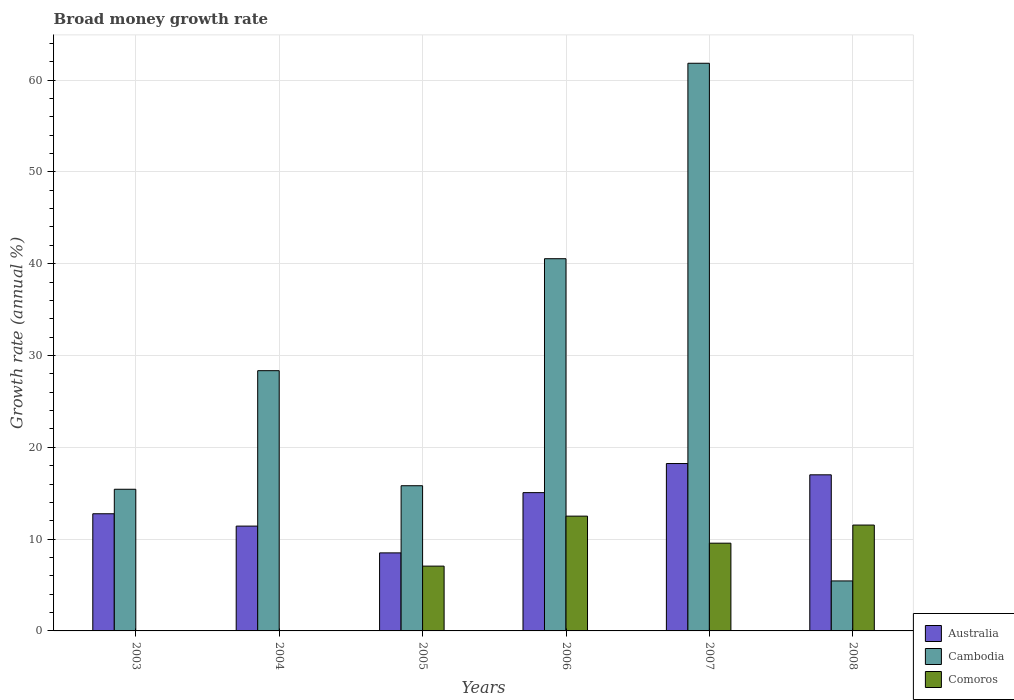Are the number of bars on each tick of the X-axis equal?
Your answer should be very brief. No. What is the growth rate in Comoros in 2008?
Provide a succinct answer. 11.53. Across all years, what is the maximum growth rate in Comoros?
Give a very brief answer. 12.5. Across all years, what is the minimum growth rate in Comoros?
Provide a succinct answer. 0. What is the total growth rate in Comoros in the graph?
Provide a short and direct response. 40.65. What is the difference between the growth rate in Cambodia in 2004 and that in 2005?
Your response must be concise. 12.53. What is the difference between the growth rate in Comoros in 2006 and the growth rate in Australia in 2004?
Your answer should be compact. 1.09. What is the average growth rate in Cambodia per year?
Offer a terse response. 27.9. In the year 2007, what is the difference between the growth rate in Cambodia and growth rate in Comoros?
Your answer should be very brief. 52.28. In how many years, is the growth rate in Cambodia greater than 2 %?
Offer a terse response. 6. What is the ratio of the growth rate in Cambodia in 2003 to that in 2004?
Provide a short and direct response. 0.54. Is the difference between the growth rate in Cambodia in 2005 and 2008 greater than the difference between the growth rate in Comoros in 2005 and 2008?
Provide a succinct answer. Yes. What is the difference between the highest and the second highest growth rate in Australia?
Provide a short and direct response. 1.23. What is the difference between the highest and the lowest growth rate in Australia?
Offer a terse response. 9.73. Is the sum of the growth rate in Cambodia in 2004 and 2005 greater than the maximum growth rate in Comoros across all years?
Give a very brief answer. Yes. Is it the case that in every year, the sum of the growth rate in Comoros and growth rate in Cambodia is greater than the growth rate in Australia?
Offer a terse response. No. How many bars are there?
Give a very brief answer. 16. Does the graph contain grids?
Ensure brevity in your answer.  Yes. How many legend labels are there?
Keep it short and to the point. 3. How are the legend labels stacked?
Make the answer very short. Vertical. What is the title of the graph?
Give a very brief answer. Broad money growth rate. Does "France" appear as one of the legend labels in the graph?
Your answer should be very brief. No. What is the label or title of the X-axis?
Your response must be concise. Years. What is the label or title of the Y-axis?
Provide a short and direct response. Growth rate (annual %). What is the Growth rate (annual %) in Australia in 2003?
Make the answer very short. 12.76. What is the Growth rate (annual %) of Cambodia in 2003?
Ensure brevity in your answer.  15.43. What is the Growth rate (annual %) of Comoros in 2003?
Provide a short and direct response. 0. What is the Growth rate (annual %) in Australia in 2004?
Provide a succinct answer. 11.42. What is the Growth rate (annual %) of Cambodia in 2004?
Provide a succinct answer. 28.35. What is the Growth rate (annual %) in Comoros in 2004?
Your answer should be very brief. 0. What is the Growth rate (annual %) in Australia in 2005?
Ensure brevity in your answer.  8.5. What is the Growth rate (annual %) in Cambodia in 2005?
Provide a succinct answer. 15.82. What is the Growth rate (annual %) of Comoros in 2005?
Keep it short and to the point. 7.06. What is the Growth rate (annual %) of Australia in 2006?
Offer a terse response. 15.06. What is the Growth rate (annual %) in Cambodia in 2006?
Offer a terse response. 40.55. What is the Growth rate (annual %) in Comoros in 2006?
Your response must be concise. 12.5. What is the Growth rate (annual %) of Australia in 2007?
Your answer should be very brief. 18.23. What is the Growth rate (annual %) in Cambodia in 2007?
Your answer should be very brief. 61.84. What is the Growth rate (annual %) of Comoros in 2007?
Keep it short and to the point. 9.56. What is the Growth rate (annual %) in Australia in 2008?
Offer a very short reply. 17. What is the Growth rate (annual %) in Cambodia in 2008?
Offer a terse response. 5.45. What is the Growth rate (annual %) in Comoros in 2008?
Provide a short and direct response. 11.53. Across all years, what is the maximum Growth rate (annual %) of Australia?
Provide a succinct answer. 18.23. Across all years, what is the maximum Growth rate (annual %) in Cambodia?
Your response must be concise. 61.84. Across all years, what is the maximum Growth rate (annual %) in Comoros?
Your response must be concise. 12.5. Across all years, what is the minimum Growth rate (annual %) in Australia?
Provide a short and direct response. 8.5. Across all years, what is the minimum Growth rate (annual %) of Cambodia?
Provide a succinct answer. 5.45. Across all years, what is the minimum Growth rate (annual %) in Comoros?
Your answer should be compact. 0. What is the total Growth rate (annual %) in Australia in the graph?
Provide a succinct answer. 82.98. What is the total Growth rate (annual %) of Cambodia in the graph?
Provide a short and direct response. 167.43. What is the total Growth rate (annual %) in Comoros in the graph?
Provide a short and direct response. 40.65. What is the difference between the Growth rate (annual %) of Australia in 2003 and that in 2004?
Your answer should be compact. 1.35. What is the difference between the Growth rate (annual %) in Cambodia in 2003 and that in 2004?
Your response must be concise. -12.92. What is the difference between the Growth rate (annual %) in Australia in 2003 and that in 2005?
Make the answer very short. 4.26. What is the difference between the Growth rate (annual %) in Cambodia in 2003 and that in 2005?
Your answer should be compact. -0.38. What is the difference between the Growth rate (annual %) of Australia in 2003 and that in 2006?
Provide a short and direct response. -2.3. What is the difference between the Growth rate (annual %) in Cambodia in 2003 and that in 2006?
Provide a succinct answer. -25.11. What is the difference between the Growth rate (annual %) of Australia in 2003 and that in 2007?
Provide a succinct answer. -5.47. What is the difference between the Growth rate (annual %) in Cambodia in 2003 and that in 2007?
Keep it short and to the point. -46.4. What is the difference between the Growth rate (annual %) of Australia in 2003 and that in 2008?
Offer a terse response. -4.24. What is the difference between the Growth rate (annual %) of Cambodia in 2003 and that in 2008?
Offer a terse response. 9.99. What is the difference between the Growth rate (annual %) of Australia in 2004 and that in 2005?
Provide a succinct answer. 2.92. What is the difference between the Growth rate (annual %) of Cambodia in 2004 and that in 2005?
Give a very brief answer. 12.53. What is the difference between the Growth rate (annual %) of Australia in 2004 and that in 2006?
Your answer should be compact. -3.64. What is the difference between the Growth rate (annual %) in Cambodia in 2004 and that in 2006?
Make the answer very short. -12.2. What is the difference between the Growth rate (annual %) in Australia in 2004 and that in 2007?
Provide a succinct answer. -6.81. What is the difference between the Growth rate (annual %) of Cambodia in 2004 and that in 2007?
Ensure brevity in your answer.  -33.49. What is the difference between the Growth rate (annual %) in Australia in 2004 and that in 2008?
Your response must be concise. -5.59. What is the difference between the Growth rate (annual %) in Cambodia in 2004 and that in 2008?
Your answer should be compact. 22.9. What is the difference between the Growth rate (annual %) of Australia in 2005 and that in 2006?
Offer a terse response. -6.56. What is the difference between the Growth rate (annual %) in Cambodia in 2005 and that in 2006?
Your answer should be very brief. -24.73. What is the difference between the Growth rate (annual %) of Comoros in 2005 and that in 2006?
Your answer should be compact. -5.45. What is the difference between the Growth rate (annual %) of Australia in 2005 and that in 2007?
Provide a short and direct response. -9.73. What is the difference between the Growth rate (annual %) of Cambodia in 2005 and that in 2007?
Keep it short and to the point. -46.02. What is the difference between the Growth rate (annual %) of Comoros in 2005 and that in 2007?
Offer a very short reply. -2.5. What is the difference between the Growth rate (annual %) of Australia in 2005 and that in 2008?
Keep it short and to the point. -8.5. What is the difference between the Growth rate (annual %) in Cambodia in 2005 and that in 2008?
Offer a terse response. 10.37. What is the difference between the Growth rate (annual %) in Comoros in 2005 and that in 2008?
Your answer should be compact. -4.47. What is the difference between the Growth rate (annual %) of Australia in 2006 and that in 2007?
Give a very brief answer. -3.17. What is the difference between the Growth rate (annual %) in Cambodia in 2006 and that in 2007?
Your answer should be compact. -21.29. What is the difference between the Growth rate (annual %) of Comoros in 2006 and that in 2007?
Ensure brevity in your answer.  2.95. What is the difference between the Growth rate (annual %) of Australia in 2006 and that in 2008?
Provide a short and direct response. -1.94. What is the difference between the Growth rate (annual %) in Cambodia in 2006 and that in 2008?
Provide a succinct answer. 35.1. What is the difference between the Growth rate (annual %) in Comoros in 2006 and that in 2008?
Keep it short and to the point. 0.97. What is the difference between the Growth rate (annual %) in Australia in 2007 and that in 2008?
Offer a very short reply. 1.23. What is the difference between the Growth rate (annual %) in Cambodia in 2007 and that in 2008?
Your response must be concise. 56.39. What is the difference between the Growth rate (annual %) in Comoros in 2007 and that in 2008?
Give a very brief answer. -1.97. What is the difference between the Growth rate (annual %) in Australia in 2003 and the Growth rate (annual %) in Cambodia in 2004?
Provide a succinct answer. -15.59. What is the difference between the Growth rate (annual %) of Australia in 2003 and the Growth rate (annual %) of Cambodia in 2005?
Offer a very short reply. -3.05. What is the difference between the Growth rate (annual %) in Australia in 2003 and the Growth rate (annual %) in Comoros in 2005?
Your answer should be very brief. 5.71. What is the difference between the Growth rate (annual %) in Cambodia in 2003 and the Growth rate (annual %) in Comoros in 2005?
Offer a terse response. 8.37. What is the difference between the Growth rate (annual %) of Australia in 2003 and the Growth rate (annual %) of Cambodia in 2006?
Your response must be concise. -27.78. What is the difference between the Growth rate (annual %) of Australia in 2003 and the Growth rate (annual %) of Comoros in 2006?
Ensure brevity in your answer.  0.26. What is the difference between the Growth rate (annual %) in Cambodia in 2003 and the Growth rate (annual %) in Comoros in 2006?
Provide a succinct answer. 2.93. What is the difference between the Growth rate (annual %) of Australia in 2003 and the Growth rate (annual %) of Cambodia in 2007?
Keep it short and to the point. -49.07. What is the difference between the Growth rate (annual %) of Australia in 2003 and the Growth rate (annual %) of Comoros in 2007?
Make the answer very short. 3.21. What is the difference between the Growth rate (annual %) of Cambodia in 2003 and the Growth rate (annual %) of Comoros in 2007?
Give a very brief answer. 5.87. What is the difference between the Growth rate (annual %) in Australia in 2003 and the Growth rate (annual %) in Cambodia in 2008?
Make the answer very short. 7.32. What is the difference between the Growth rate (annual %) of Australia in 2003 and the Growth rate (annual %) of Comoros in 2008?
Your answer should be very brief. 1.23. What is the difference between the Growth rate (annual %) of Cambodia in 2003 and the Growth rate (annual %) of Comoros in 2008?
Keep it short and to the point. 3.9. What is the difference between the Growth rate (annual %) of Australia in 2004 and the Growth rate (annual %) of Cambodia in 2005?
Offer a very short reply. -4.4. What is the difference between the Growth rate (annual %) of Australia in 2004 and the Growth rate (annual %) of Comoros in 2005?
Keep it short and to the point. 4.36. What is the difference between the Growth rate (annual %) of Cambodia in 2004 and the Growth rate (annual %) of Comoros in 2005?
Provide a short and direct response. 21.29. What is the difference between the Growth rate (annual %) in Australia in 2004 and the Growth rate (annual %) in Cambodia in 2006?
Ensure brevity in your answer.  -29.13. What is the difference between the Growth rate (annual %) of Australia in 2004 and the Growth rate (annual %) of Comoros in 2006?
Keep it short and to the point. -1.09. What is the difference between the Growth rate (annual %) in Cambodia in 2004 and the Growth rate (annual %) in Comoros in 2006?
Ensure brevity in your answer.  15.84. What is the difference between the Growth rate (annual %) of Australia in 2004 and the Growth rate (annual %) of Cambodia in 2007?
Offer a terse response. -50.42. What is the difference between the Growth rate (annual %) of Australia in 2004 and the Growth rate (annual %) of Comoros in 2007?
Your answer should be compact. 1.86. What is the difference between the Growth rate (annual %) in Cambodia in 2004 and the Growth rate (annual %) in Comoros in 2007?
Keep it short and to the point. 18.79. What is the difference between the Growth rate (annual %) of Australia in 2004 and the Growth rate (annual %) of Cambodia in 2008?
Provide a short and direct response. 5.97. What is the difference between the Growth rate (annual %) in Australia in 2004 and the Growth rate (annual %) in Comoros in 2008?
Your response must be concise. -0.11. What is the difference between the Growth rate (annual %) in Cambodia in 2004 and the Growth rate (annual %) in Comoros in 2008?
Your answer should be very brief. 16.82. What is the difference between the Growth rate (annual %) in Australia in 2005 and the Growth rate (annual %) in Cambodia in 2006?
Provide a short and direct response. -32.05. What is the difference between the Growth rate (annual %) in Australia in 2005 and the Growth rate (annual %) in Comoros in 2006?
Offer a terse response. -4. What is the difference between the Growth rate (annual %) in Cambodia in 2005 and the Growth rate (annual %) in Comoros in 2006?
Provide a short and direct response. 3.31. What is the difference between the Growth rate (annual %) of Australia in 2005 and the Growth rate (annual %) of Cambodia in 2007?
Provide a short and direct response. -53.34. What is the difference between the Growth rate (annual %) of Australia in 2005 and the Growth rate (annual %) of Comoros in 2007?
Your answer should be very brief. -1.06. What is the difference between the Growth rate (annual %) in Cambodia in 2005 and the Growth rate (annual %) in Comoros in 2007?
Your response must be concise. 6.26. What is the difference between the Growth rate (annual %) of Australia in 2005 and the Growth rate (annual %) of Cambodia in 2008?
Ensure brevity in your answer.  3.05. What is the difference between the Growth rate (annual %) in Australia in 2005 and the Growth rate (annual %) in Comoros in 2008?
Ensure brevity in your answer.  -3.03. What is the difference between the Growth rate (annual %) of Cambodia in 2005 and the Growth rate (annual %) of Comoros in 2008?
Provide a short and direct response. 4.28. What is the difference between the Growth rate (annual %) in Australia in 2006 and the Growth rate (annual %) in Cambodia in 2007?
Provide a succinct answer. -46.77. What is the difference between the Growth rate (annual %) of Australia in 2006 and the Growth rate (annual %) of Comoros in 2007?
Provide a short and direct response. 5.5. What is the difference between the Growth rate (annual %) in Cambodia in 2006 and the Growth rate (annual %) in Comoros in 2007?
Your answer should be compact. 30.99. What is the difference between the Growth rate (annual %) of Australia in 2006 and the Growth rate (annual %) of Cambodia in 2008?
Your answer should be compact. 9.62. What is the difference between the Growth rate (annual %) in Australia in 2006 and the Growth rate (annual %) in Comoros in 2008?
Ensure brevity in your answer.  3.53. What is the difference between the Growth rate (annual %) in Cambodia in 2006 and the Growth rate (annual %) in Comoros in 2008?
Offer a terse response. 29.01. What is the difference between the Growth rate (annual %) in Australia in 2007 and the Growth rate (annual %) in Cambodia in 2008?
Offer a terse response. 12.79. What is the difference between the Growth rate (annual %) of Australia in 2007 and the Growth rate (annual %) of Comoros in 2008?
Make the answer very short. 6.7. What is the difference between the Growth rate (annual %) of Cambodia in 2007 and the Growth rate (annual %) of Comoros in 2008?
Offer a very short reply. 50.3. What is the average Growth rate (annual %) of Australia per year?
Offer a very short reply. 13.83. What is the average Growth rate (annual %) of Cambodia per year?
Provide a short and direct response. 27.9. What is the average Growth rate (annual %) in Comoros per year?
Provide a succinct answer. 6.78. In the year 2003, what is the difference between the Growth rate (annual %) of Australia and Growth rate (annual %) of Cambodia?
Ensure brevity in your answer.  -2.67. In the year 2004, what is the difference between the Growth rate (annual %) of Australia and Growth rate (annual %) of Cambodia?
Keep it short and to the point. -16.93. In the year 2005, what is the difference between the Growth rate (annual %) in Australia and Growth rate (annual %) in Cambodia?
Keep it short and to the point. -7.32. In the year 2005, what is the difference between the Growth rate (annual %) in Australia and Growth rate (annual %) in Comoros?
Your answer should be compact. 1.44. In the year 2005, what is the difference between the Growth rate (annual %) of Cambodia and Growth rate (annual %) of Comoros?
Provide a short and direct response. 8.76. In the year 2006, what is the difference between the Growth rate (annual %) of Australia and Growth rate (annual %) of Cambodia?
Offer a terse response. -25.48. In the year 2006, what is the difference between the Growth rate (annual %) in Australia and Growth rate (annual %) in Comoros?
Make the answer very short. 2.56. In the year 2006, what is the difference between the Growth rate (annual %) in Cambodia and Growth rate (annual %) in Comoros?
Make the answer very short. 28.04. In the year 2007, what is the difference between the Growth rate (annual %) in Australia and Growth rate (annual %) in Cambodia?
Provide a succinct answer. -43.6. In the year 2007, what is the difference between the Growth rate (annual %) in Australia and Growth rate (annual %) in Comoros?
Offer a very short reply. 8.67. In the year 2007, what is the difference between the Growth rate (annual %) of Cambodia and Growth rate (annual %) of Comoros?
Make the answer very short. 52.28. In the year 2008, what is the difference between the Growth rate (annual %) in Australia and Growth rate (annual %) in Cambodia?
Ensure brevity in your answer.  11.56. In the year 2008, what is the difference between the Growth rate (annual %) of Australia and Growth rate (annual %) of Comoros?
Offer a terse response. 5.47. In the year 2008, what is the difference between the Growth rate (annual %) in Cambodia and Growth rate (annual %) in Comoros?
Offer a very short reply. -6.09. What is the ratio of the Growth rate (annual %) in Australia in 2003 to that in 2004?
Provide a short and direct response. 1.12. What is the ratio of the Growth rate (annual %) of Cambodia in 2003 to that in 2004?
Provide a succinct answer. 0.54. What is the ratio of the Growth rate (annual %) in Australia in 2003 to that in 2005?
Your response must be concise. 1.5. What is the ratio of the Growth rate (annual %) in Cambodia in 2003 to that in 2005?
Your answer should be compact. 0.98. What is the ratio of the Growth rate (annual %) in Australia in 2003 to that in 2006?
Offer a very short reply. 0.85. What is the ratio of the Growth rate (annual %) in Cambodia in 2003 to that in 2006?
Provide a short and direct response. 0.38. What is the ratio of the Growth rate (annual %) in Australia in 2003 to that in 2007?
Make the answer very short. 0.7. What is the ratio of the Growth rate (annual %) in Cambodia in 2003 to that in 2007?
Provide a short and direct response. 0.25. What is the ratio of the Growth rate (annual %) of Australia in 2003 to that in 2008?
Offer a terse response. 0.75. What is the ratio of the Growth rate (annual %) of Cambodia in 2003 to that in 2008?
Your response must be concise. 2.83. What is the ratio of the Growth rate (annual %) in Australia in 2004 to that in 2005?
Ensure brevity in your answer.  1.34. What is the ratio of the Growth rate (annual %) of Cambodia in 2004 to that in 2005?
Ensure brevity in your answer.  1.79. What is the ratio of the Growth rate (annual %) of Australia in 2004 to that in 2006?
Provide a short and direct response. 0.76. What is the ratio of the Growth rate (annual %) of Cambodia in 2004 to that in 2006?
Your answer should be compact. 0.7. What is the ratio of the Growth rate (annual %) of Australia in 2004 to that in 2007?
Offer a very short reply. 0.63. What is the ratio of the Growth rate (annual %) in Cambodia in 2004 to that in 2007?
Your answer should be compact. 0.46. What is the ratio of the Growth rate (annual %) in Australia in 2004 to that in 2008?
Provide a short and direct response. 0.67. What is the ratio of the Growth rate (annual %) in Cambodia in 2004 to that in 2008?
Your response must be concise. 5.21. What is the ratio of the Growth rate (annual %) of Australia in 2005 to that in 2006?
Your answer should be compact. 0.56. What is the ratio of the Growth rate (annual %) of Cambodia in 2005 to that in 2006?
Give a very brief answer. 0.39. What is the ratio of the Growth rate (annual %) of Comoros in 2005 to that in 2006?
Provide a succinct answer. 0.56. What is the ratio of the Growth rate (annual %) in Australia in 2005 to that in 2007?
Provide a succinct answer. 0.47. What is the ratio of the Growth rate (annual %) of Cambodia in 2005 to that in 2007?
Keep it short and to the point. 0.26. What is the ratio of the Growth rate (annual %) of Comoros in 2005 to that in 2007?
Offer a very short reply. 0.74. What is the ratio of the Growth rate (annual %) in Australia in 2005 to that in 2008?
Keep it short and to the point. 0.5. What is the ratio of the Growth rate (annual %) of Cambodia in 2005 to that in 2008?
Your response must be concise. 2.9. What is the ratio of the Growth rate (annual %) in Comoros in 2005 to that in 2008?
Provide a short and direct response. 0.61. What is the ratio of the Growth rate (annual %) of Australia in 2006 to that in 2007?
Offer a terse response. 0.83. What is the ratio of the Growth rate (annual %) in Cambodia in 2006 to that in 2007?
Keep it short and to the point. 0.66. What is the ratio of the Growth rate (annual %) in Comoros in 2006 to that in 2007?
Provide a short and direct response. 1.31. What is the ratio of the Growth rate (annual %) in Australia in 2006 to that in 2008?
Provide a succinct answer. 0.89. What is the ratio of the Growth rate (annual %) in Cambodia in 2006 to that in 2008?
Offer a terse response. 7.45. What is the ratio of the Growth rate (annual %) in Comoros in 2006 to that in 2008?
Make the answer very short. 1.08. What is the ratio of the Growth rate (annual %) in Australia in 2007 to that in 2008?
Offer a terse response. 1.07. What is the ratio of the Growth rate (annual %) of Cambodia in 2007 to that in 2008?
Offer a terse response. 11.35. What is the ratio of the Growth rate (annual %) in Comoros in 2007 to that in 2008?
Make the answer very short. 0.83. What is the difference between the highest and the second highest Growth rate (annual %) of Australia?
Make the answer very short. 1.23. What is the difference between the highest and the second highest Growth rate (annual %) in Cambodia?
Your answer should be very brief. 21.29. What is the difference between the highest and the second highest Growth rate (annual %) in Comoros?
Provide a short and direct response. 0.97. What is the difference between the highest and the lowest Growth rate (annual %) of Australia?
Your answer should be very brief. 9.73. What is the difference between the highest and the lowest Growth rate (annual %) in Cambodia?
Keep it short and to the point. 56.39. What is the difference between the highest and the lowest Growth rate (annual %) in Comoros?
Give a very brief answer. 12.5. 